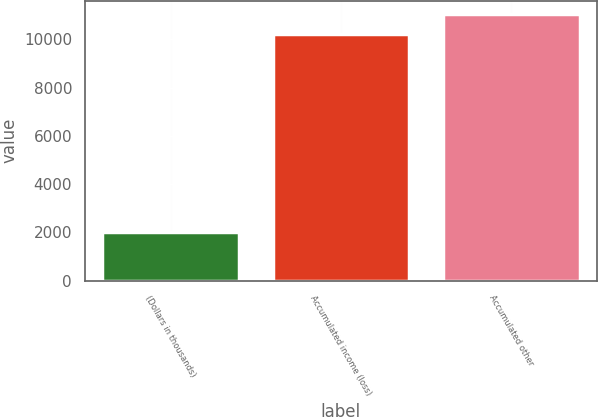<chart> <loc_0><loc_0><loc_500><loc_500><bar_chart><fcel>(Dollars in thousands)<fcel>Accumulated income (loss)<fcel>Accumulated other<nl><fcel>2012<fcel>10231<fcel>11052.9<nl></chart> 